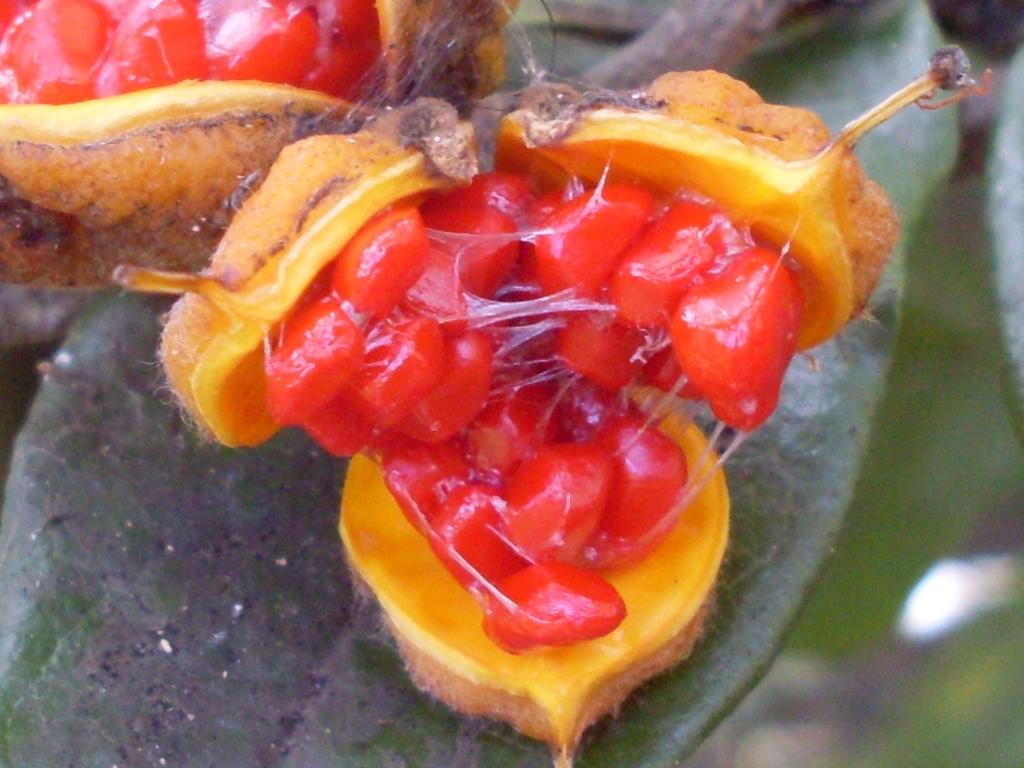How many fruits can be seen in the image? There are two fruits in the image. What else is visible in the image besides the fruits? Leaves are visible in the image. How does the jellyfish react to the presence of the fruits in the image? There is no jellyfish present in the image, so it cannot react to the fruits. 